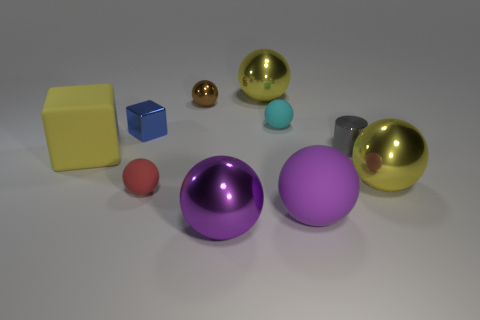How many objects are large yellow objects on the right side of the shiny block or rubber balls in front of the small metal block?
Offer a terse response. 4. Are there any tiny blue metallic things that are to the right of the large yellow ball that is behind the blue metallic object?
Offer a terse response. No. There is a red object that is the same size as the metal cylinder; what is its shape?
Make the answer very short. Sphere. What number of things are big yellow metallic things in front of the tiny brown object or large red cubes?
Ensure brevity in your answer.  1. What number of other things are made of the same material as the tiny blue cube?
Your answer should be very brief. 5. What shape is the large shiny object that is the same color as the large rubber ball?
Your response must be concise. Sphere. There is a cyan sphere in front of the small brown shiny ball; how big is it?
Ensure brevity in your answer.  Small. What is the shape of the tiny red thing that is the same material as the yellow cube?
Provide a succinct answer. Sphere. Is the material of the cyan object the same as the small thing to the left of the tiny red object?
Your answer should be very brief. No. Is the shape of the big purple object behind the purple shiny thing the same as  the small gray object?
Provide a succinct answer. No. 